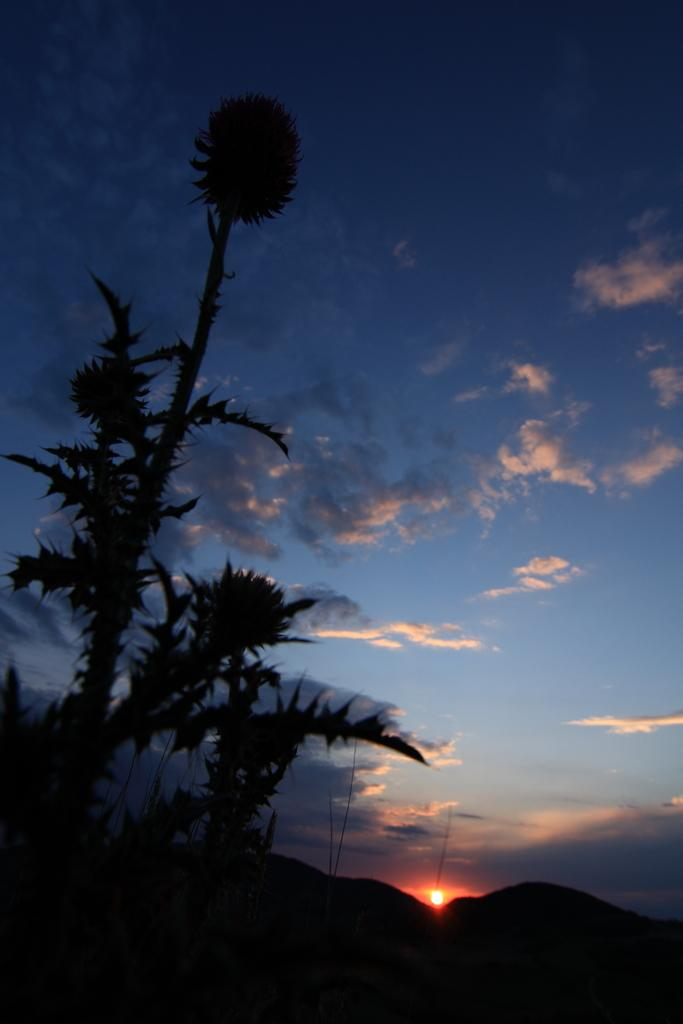What is visible on the ground in the image? The ground is visible in the image. What type of vegetation can be seen in the image? There are plants in the image. What is visible in the sky in the image? The sky is visible in the image, and clouds and the sun are present. What type of smell can be detected from the plants in the image? There is no information about the smell of the plants in the image, so it cannot be determined. 